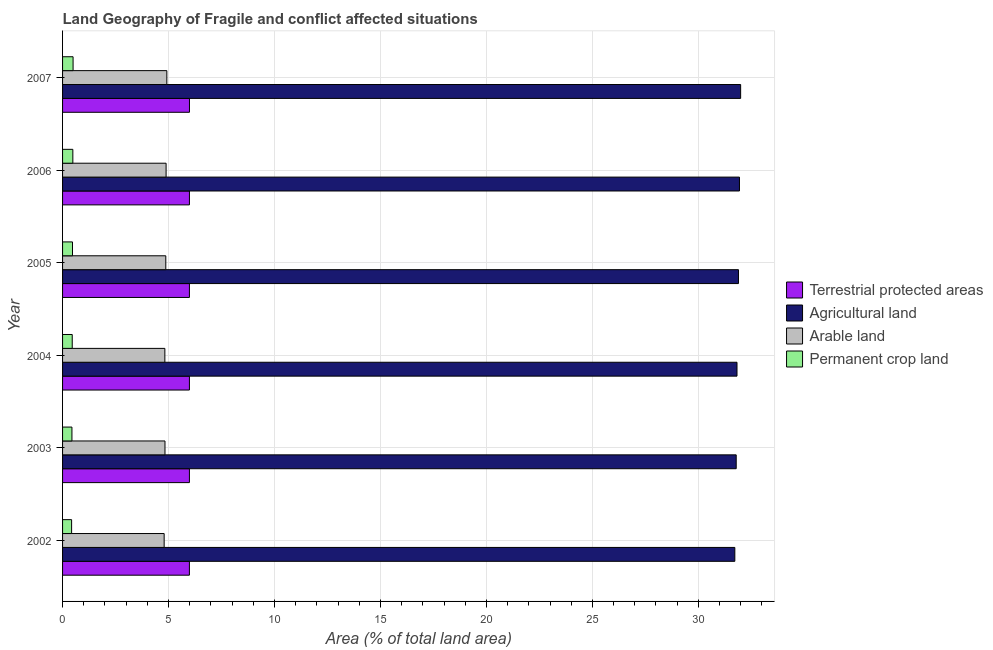How many different coloured bars are there?
Make the answer very short. 4. Are the number of bars per tick equal to the number of legend labels?
Make the answer very short. Yes. How many bars are there on the 5th tick from the top?
Ensure brevity in your answer.  4. How many bars are there on the 1st tick from the bottom?
Provide a short and direct response. 4. What is the label of the 2nd group of bars from the top?
Your answer should be compact. 2006. What is the percentage of land under terrestrial protection in 2002?
Give a very brief answer. 5.98. Across all years, what is the maximum percentage of area under arable land?
Your response must be concise. 4.92. Across all years, what is the minimum percentage of land under terrestrial protection?
Your response must be concise. 5.98. In which year was the percentage of land under terrestrial protection maximum?
Your answer should be very brief. 2007. In which year was the percentage of area under arable land minimum?
Your response must be concise. 2002. What is the total percentage of area under agricultural land in the graph?
Your answer should be compact. 191.16. What is the difference between the percentage of area under arable land in 2002 and that in 2005?
Provide a succinct answer. -0.08. What is the difference between the percentage of area under arable land in 2004 and the percentage of area under agricultural land in 2007?
Provide a succinct answer. -27.17. What is the average percentage of area under permanent crop land per year?
Your answer should be very brief. 0.46. In the year 2002, what is the difference between the percentage of land under terrestrial protection and percentage of area under agricultural land?
Your response must be concise. -25.74. In how many years, is the percentage of area under agricultural land greater than 26 %?
Offer a very short reply. 6. What is the ratio of the percentage of area under permanent crop land in 2005 to that in 2007?
Your answer should be very brief. 0.94. What is the difference between the highest and the second highest percentage of area under agricultural land?
Provide a succinct answer. 0.06. What is the difference between the highest and the lowest percentage of area under arable land?
Provide a short and direct response. 0.13. In how many years, is the percentage of area under permanent crop land greater than the average percentage of area under permanent crop land taken over all years?
Ensure brevity in your answer.  3. What does the 2nd bar from the top in 2007 represents?
Ensure brevity in your answer.  Arable land. What does the 1st bar from the bottom in 2003 represents?
Make the answer very short. Terrestrial protected areas. How many years are there in the graph?
Provide a succinct answer. 6. Where does the legend appear in the graph?
Provide a succinct answer. Center right. How many legend labels are there?
Offer a terse response. 4. What is the title of the graph?
Provide a succinct answer. Land Geography of Fragile and conflict affected situations. Does "Third 20% of population" appear as one of the legend labels in the graph?
Give a very brief answer. No. What is the label or title of the X-axis?
Ensure brevity in your answer.  Area (% of total land area). What is the Area (% of total land area) in Terrestrial protected areas in 2002?
Give a very brief answer. 5.98. What is the Area (% of total land area) in Agricultural land in 2002?
Your answer should be compact. 31.72. What is the Area (% of total land area) of Arable land in 2002?
Provide a succinct answer. 4.79. What is the Area (% of total land area) of Permanent crop land in 2002?
Your answer should be very brief. 0.43. What is the Area (% of total land area) in Terrestrial protected areas in 2003?
Give a very brief answer. 5.99. What is the Area (% of total land area) of Agricultural land in 2003?
Your answer should be compact. 31.79. What is the Area (% of total land area) in Arable land in 2003?
Offer a terse response. 4.83. What is the Area (% of total land area) of Permanent crop land in 2003?
Provide a succinct answer. 0.44. What is the Area (% of total land area) in Terrestrial protected areas in 2004?
Keep it short and to the point. 5.99. What is the Area (% of total land area) in Agricultural land in 2004?
Offer a terse response. 31.82. What is the Area (% of total land area) in Arable land in 2004?
Offer a terse response. 4.83. What is the Area (% of total land area) in Permanent crop land in 2004?
Your response must be concise. 0.46. What is the Area (% of total land area) of Terrestrial protected areas in 2005?
Provide a succinct answer. 5.99. What is the Area (% of total land area) of Agricultural land in 2005?
Offer a very short reply. 31.89. What is the Area (% of total land area) in Arable land in 2005?
Provide a short and direct response. 4.87. What is the Area (% of total land area) in Permanent crop land in 2005?
Your answer should be very brief. 0.47. What is the Area (% of total land area) of Terrestrial protected areas in 2006?
Keep it short and to the point. 5.99. What is the Area (% of total land area) in Agricultural land in 2006?
Your response must be concise. 31.94. What is the Area (% of total land area) in Arable land in 2006?
Offer a very short reply. 4.89. What is the Area (% of total land area) in Permanent crop land in 2006?
Make the answer very short. 0.48. What is the Area (% of total land area) in Terrestrial protected areas in 2007?
Your answer should be very brief. 5.99. What is the Area (% of total land area) of Agricultural land in 2007?
Ensure brevity in your answer.  32. What is the Area (% of total land area) of Arable land in 2007?
Give a very brief answer. 4.92. What is the Area (% of total land area) of Permanent crop land in 2007?
Provide a short and direct response. 0.5. Across all years, what is the maximum Area (% of total land area) in Terrestrial protected areas?
Ensure brevity in your answer.  5.99. Across all years, what is the maximum Area (% of total land area) in Agricultural land?
Your answer should be very brief. 32. Across all years, what is the maximum Area (% of total land area) in Arable land?
Offer a very short reply. 4.92. Across all years, what is the maximum Area (% of total land area) in Permanent crop land?
Ensure brevity in your answer.  0.5. Across all years, what is the minimum Area (% of total land area) in Terrestrial protected areas?
Offer a very short reply. 5.98. Across all years, what is the minimum Area (% of total land area) in Agricultural land?
Offer a very short reply. 31.72. Across all years, what is the minimum Area (% of total land area) in Arable land?
Your answer should be very brief. 4.79. Across all years, what is the minimum Area (% of total land area) in Permanent crop land?
Your answer should be very brief. 0.43. What is the total Area (% of total land area) of Terrestrial protected areas in the graph?
Make the answer very short. 35.92. What is the total Area (% of total land area) of Agricultural land in the graph?
Give a very brief answer. 191.16. What is the total Area (% of total land area) in Arable land in the graph?
Your answer should be very brief. 29.13. What is the total Area (% of total land area) in Permanent crop land in the graph?
Your response must be concise. 2.78. What is the difference between the Area (% of total land area) in Terrestrial protected areas in 2002 and that in 2003?
Offer a very short reply. -0. What is the difference between the Area (% of total land area) of Agricultural land in 2002 and that in 2003?
Your response must be concise. -0.07. What is the difference between the Area (% of total land area) of Arable land in 2002 and that in 2003?
Provide a short and direct response. -0.04. What is the difference between the Area (% of total land area) in Permanent crop land in 2002 and that in 2003?
Provide a succinct answer. -0.01. What is the difference between the Area (% of total land area) of Terrestrial protected areas in 2002 and that in 2004?
Ensure brevity in your answer.  -0. What is the difference between the Area (% of total land area) in Agricultural land in 2002 and that in 2004?
Your answer should be compact. -0.1. What is the difference between the Area (% of total land area) in Arable land in 2002 and that in 2004?
Provide a succinct answer. -0.03. What is the difference between the Area (% of total land area) in Permanent crop land in 2002 and that in 2004?
Provide a short and direct response. -0.03. What is the difference between the Area (% of total land area) in Terrestrial protected areas in 2002 and that in 2005?
Give a very brief answer. -0. What is the difference between the Area (% of total land area) of Agricultural land in 2002 and that in 2005?
Ensure brevity in your answer.  -0.17. What is the difference between the Area (% of total land area) in Arable land in 2002 and that in 2005?
Provide a short and direct response. -0.08. What is the difference between the Area (% of total land area) of Permanent crop land in 2002 and that in 2005?
Your answer should be very brief. -0.04. What is the difference between the Area (% of total land area) in Terrestrial protected areas in 2002 and that in 2006?
Make the answer very short. -0. What is the difference between the Area (% of total land area) of Agricultural land in 2002 and that in 2006?
Your answer should be very brief. -0.22. What is the difference between the Area (% of total land area) of Arable land in 2002 and that in 2006?
Offer a terse response. -0.09. What is the difference between the Area (% of total land area) of Permanent crop land in 2002 and that in 2006?
Your answer should be very brief. -0.06. What is the difference between the Area (% of total land area) in Terrestrial protected areas in 2002 and that in 2007?
Offer a very short reply. -0. What is the difference between the Area (% of total land area) of Agricultural land in 2002 and that in 2007?
Provide a short and direct response. -0.27. What is the difference between the Area (% of total land area) in Arable land in 2002 and that in 2007?
Give a very brief answer. -0.13. What is the difference between the Area (% of total land area) of Permanent crop land in 2002 and that in 2007?
Offer a very short reply. -0.07. What is the difference between the Area (% of total land area) in Terrestrial protected areas in 2003 and that in 2004?
Your answer should be compact. 0. What is the difference between the Area (% of total land area) of Agricultural land in 2003 and that in 2004?
Give a very brief answer. -0.04. What is the difference between the Area (% of total land area) of Arable land in 2003 and that in 2004?
Keep it short and to the point. 0.01. What is the difference between the Area (% of total land area) in Permanent crop land in 2003 and that in 2004?
Ensure brevity in your answer.  -0.01. What is the difference between the Area (% of total land area) of Agricultural land in 2003 and that in 2005?
Offer a terse response. -0.11. What is the difference between the Area (% of total land area) of Arable land in 2003 and that in 2005?
Your response must be concise. -0.04. What is the difference between the Area (% of total land area) of Permanent crop land in 2003 and that in 2005?
Your answer should be very brief. -0.03. What is the difference between the Area (% of total land area) of Terrestrial protected areas in 2003 and that in 2006?
Your response must be concise. -0. What is the difference between the Area (% of total land area) in Agricultural land in 2003 and that in 2006?
Make the answer very short. -0.15. What is the difference between the Area (% of total land area) of Arable land in 2003 and that in 2006?
Ensure brevity in your answer.  -0.05. What is the difference between the Area (% of total land area) of Permanent crop land in 2003 and that in 2006?
Your answer should be compact. -0.04. What is the difference between the Area (% of total land area) in Terrestrial protected areas in 2003 and that in 2007?
Make the answer very short. -0. What is the difference between the Area (% of total land area) of Agricultural land in 2003 and that in 2007?
Offer a terse response. -0.21. What is the difference between the Area (% of total land area) in Arable land in 2003 and that in 2007?
Offer a terse response. -0.09. What is the difference between the Area (% of total land area) in Permanent crop land in 2003 and that in 2007?
Ensure brevity in your answer.  -0.05. What is the difference between the Area (% of total land area) of Terrestrial protected areas in 2004 and that in 2005?
Keep it short and to the point. -0. What is the difference between the Area (% of total land area) of Agricultural land in 2004 and that in 2005?
Provide a succinct answer. -0.07. What is the difference between the Area (% of total land area) in Arable land in 2004 and that in 2005?
Make the answer very short. -0.04. What is the difference between the Area (% of total land area) in Permanent crop land in 2004 and that in 2005?
Ensure brevity in your answer.  -0.01. What is the difference between the Area (% of total land area) in Terrestrial protected areas in 2004 and that in 2006?
Your answer should be very brief. -0. What is the difference between the Area (% of total land area) in Agricultural land in 2004 and that in 2006?
Give a very brief answer. -0.12. What is the difference between the Area (% of total land area) in Arable land in 2004 and that in 2006?
Keep it short and to the point. -0.06. What is the difference between the Area (% of total land area) in Permanent crop land in 2004 and that in 2006?
Give a very brief answer. -0.03. What is the difference between the Area (% of total land area) of Terrestrial protected areas in 2004 and that in 2007?
Offer a terse response. -0. What is the difference between the Area (% of total land area) of Agricultural land in 2004 and that in 2007?
Offer a very short reply. -0.17. What is the difference between the Area (% of total land area) of Arable land in 2004 and that in 2007?
Provide a short and direct response. -0.09. What is the difference between the Area (% of total land area) in Permanent crop land in 2004 and that in 2007?
Keep it short and to the point. -0.04. What is the difference between the Area (% of total land area) of Terrestrial protected areas in 2005 and that in 2006?
Your answer should be very brief. -0. What is the difference between the Area (% of total land area) of Agricultural land in 2005 and that in 2006?
Ensure brevity in your answer.  -0.05. What is the difference between the Area (% of total land area) in Arable land in 2005 and that in 2006?
Your answer should be very brief. -0.01. What is the difference between the Area (% of total land area) in Permanent crop land in 2005 and that in 2006?
Offer a terse response. -0.02. What is the difference between the Area (% of total land area) of Terrestrial protected areas in 2005 and that in 2007?
Your answer should be compact. -0. What is the difference between the Area (% of total land area) of Agricultural land in 2005 and that in 2007?
Give a very brief answer. -0.1. What is the difference between the Area (% of total land area) of Arable land in 2005 and that in 2007?
Provide a succinct answer. -0.05. What is the difference between the Area (% of total land area) of Permanent crop land in 2005 and that in 2007?
Your response must be concise. -0.03. What is the difference between the Area (% of total land area) in Terrestrial protected areas in 2006 and that in 2007?
Your response must be concise. -0. What is the difference between the Area (% of total land area) of Agricultural land in 2006 and that in 2007?
Give a very brief answer. -0.05. What is the difference between the Area (% of total land area) in Arable land in 2006 and that in 2007?
Provide a short and direct response. -0.03. What is the difference between the Area (% of total land area) of Permanent crop land in 2006 and that in 2007?
Provide a short and direct response. -0.01. What is the difference between the Area (% of total land area) of Terrestrial protected areas in 2002 and the Area (% of total land area) of Agricultural land in 2003?
Make the answer very short. -25.8. What is the difference between the Area (% of total land area) in Terrestrial protected areas in 2002 and the Area (% of total land area) in Arable land in 2003?
Your answer should be compact. 1.15. What is the difference between the Area (% of total land area) in Terrestrial protected areas in 2002 and the Area (% of total land area) in Permanent crop land in 2003?
Your response must be concise. 5.54. What is the difference between the Area (% of total land area) in Agricultural land in 2002 and the Area (% of total land area) in Arable land in 2003?
Provide a succinct answer. 26.89. What is the difference between the Area (% of total land area) of Agricultural land in 2002 and the Area (% of total land area) of Permanent crop land in 2003?
Your answer should be very brief. 31.28. What is the difference between the Area (% of total land area) of Arable land in 2002 and the Area (% of total land area) of Permanent crop land in 2003?
Provide a succinct answer. 4.35. What is the difference between the Area (% of total land area) of Terrestrial protected areas in 2002 and the Area (% of total land area) of Agricultural land in 2004?
Provide a short and direct response. -25.84. What is the difference between the Area (% of total land area) of Terrestrial protected areas in 2002 and the Area (% of total land area) of Arable land in 2004?
Keep it short and to the point. 1.16. What is the difference between the Area (% of total land area) in Terrestrial protected areas in 2002 and the Area (% of total land area) in Permanent crop land in 2004?
Provide a succinct answer. 5.53. What is the difference between the Area (% of total land area) of Agricultural land in 2002 and the Area (% of total land area) of Arable land in 2004?
Ensure brevity in your answer.  26.89. What is the difference between the Area (% of total land area) of Agricultural land in 2002 and the Area (% of total land area) of Permanent crop land in 2004?
Your answer should be very brief. 31.27. What is the difference between the Area (% of total land area) in Arable land in 2002 and the Area (% of total land area) in Permanent crop land in 2004?
Ensure brevity in your answer.  4.34. What is the difference between the Area (% of total land area) of Terrestrial protected areas in 2002 and the Area (% of total land area) of Agricultural land in 2005?
Provide a short and direct response. -25.91. What is the difference between the Area (% of total land area) in Terrestrial protected areas in 2002 and the Area (% of total land area) in Arable land in 2005?
Make the answer very short. 1.11. What is the difference between the Area (% of total land area) of Terrestrial protected areas in 2002 and the Area (% of total land area) of Permanent crop land in 2005?
Your answer should be compact. 5.52. What is the difference between the Area (% of total land area) in Agricultural land in 2002 and the Area (% of total land area) in Arable land in 2005?
Your answer should be very brief. 26.85. What is the difference between the Area (% of total land area) in Agricultural land in 2002 and the Area (% of total land area) in Permanent crop land in 2005?
Ensure brevity in your answer.  31.25. What is the difference between the Area (% of total land area) in Arable land in 2002 and the Area (% of total land area) in Permanent crop land in 2005?
Give a very brief answer. 4.32. What is the difference between the Area (% of total land area) in Terrestrial protected areas in 2002 and the Area (% of total land area) in Agricultural land in 2006?
Offer a very short reply. -25.96. What is the difference between the Area (% of total land area) of Terrestrial protected areas in 2002 and the Area (% of total land area) of Arable land in 2006?
Ensure brevity in your answer.  1.1. What is the difference between the Area (% of total land area) in Terrestrial protected areas in 2002 and the Area (% of total land area) in Permanent crop land in 2006?
Provide a succinct answer. 5.5. What is the difference between the Area (% of total land area) in Agricultural land in 2002 and the Area (% of total land area) in Arable land in 2006?
Offer a very short reply. 26.84. What is the difference between the Area (% of total land area) of Agricultural land in 2002 and the Area (% of total land area) of Permanent crop land in 2006?
Your response must be concise. 31.24. What is the difference between the Area (% of total land area) of Arable land in 2002 and the Area (% of total land area) of Permanent crop land in 2006?
Provide a succinct answer. 4.31. What is the difference between the Area (% of total land area) of Terrestrial protected areas in 2002 and the Area (% of total land area) of Agricultural land in 2007?
Give a very brief answer. -26.01. What is the difference between the Area (% of total land area) in Terrestrial protected areas in 2002 and the Area (% of total land area) in Arable land in 2007?
Offer a terse response. 1.06. What is the difference between the Area (% of total land area) in Terrestrial protected areas in 2002 and the Area (% of total land area) in Permanent crop land in 2007?
Your answer should be compact. 5.49. What is the difference between the Area (% of total land area) in Agricultural land in 2002 and the Area (% of total land area) in Arable land in 2007?
Provide a succinct answer. 26.8. What is the difference between the Area (% of total land area) in Agricultural land in 2002 and the Area (% of total land area) in Permanent crop land in 2007?
Ensure brevity in your answer.  31.23. What is the difference between the Area (% of total land area) in Arable land in 2002 and the Area (% of total land area) in Permanent crop land in 2007?
Your response must be concise. 4.3. What is the difference between the Area (% of total land area) of Terrestrial protected areas in 2003 and the Area (% of total land area) of Agricultural land in 2004?
Provide a succinct answer. -25.84. What is the difference between the Area (% of total land area) in Terrestrial protected areas in 2003 and the Area (% of total land area) in Arable land in 2004?
Offer a very short reply. 1.16. What is the difference between the Area (% of total land area) of Terrestrial protected areas in 2003 and the Area (% of total land area) of Permanent crop land in 2004?
Offer a terse response. 5.53. What is the difference between the Area (% of total land area) in Agricultural land in 2003 and the Area (% of total land area) in Arable land in 2004?
Provide a short and direct response. 26.96. What is the difference between the Area (% of total land area) in Agricultural land in 2003 and the Area (% of total land area) in Permanent crop land in 2004?
Provide a short and direct response. 31.33. What is the difference between the Area (% of total land area) in Arable land in 2003 and the Area (% of total land area) in Permanent crop land in 2004?
Provide a succinct answer. 4.38. What is the difference between the Area (% of total land area) of Terrestrial protected areas in 2003 and the Area (% of total land area) of Agricultural land in 2005?
Ensure brevity in your answer.  -25.91. What is the difference between the Area (% of total land area) in Terrestrial protected areas in 2003 and the Area (% of total land area) in Arable land in 2005?
Your answer should be compact. 1.12. What is the difference between the Area (% of total land area) of Terrestrial protected areas in 2003 and the Area (% of total land area) of Permanent crop land in 2005?
Your response must be concise. 5.52. What is the difference between the Area (% of total land area) in Agricultural land in 2003 and the Area (% of total land area) in Arable land in 2005?
Keep it short and to the point. 26.92. What is the difference between the Area (% of total land area) of Agricultural land in 2003 and the Area (% of total land area) of Permanent crop land in 2005?
Offer a terse response. 31.32. What is the difference between the Area (% of total land area) of Arable land in 2003 and the Area (% of total land area) of Permanent crop land in 2005?
Your answer should be very brief. 4.36. What is the difference between the Area (% of total land area) in Terrestrial protected areas in 2003 and the Area (% of total land area) in Agricultural land in 2006?
Offer a very short reply. -25.95. What is the difference between the Area (% of total land area) of Terrestrial protected areas in 2003 and the Area (% of total land area) of Arable land in 2006?
Offer a terse response. 1.1. What is the difference between the Area (% of total land area) in Terrestrial protected areas in 2003 and the Area (% of total land area) in Permanent crop land in 2006?
Provide a succinct answer. 5.5. What is the difference between the Area (% of total land area) of Agricultural land in 2003 and the Area (% of total land area) of Arable land in 2006?
Provide a short and direct response. 26.9. What is the difference between the Area (% of total land area) in Agricultural land in 2003 and the Area (% of total land area) in Permanent crop land in 2006?
Your answer should be compact. 31.3. What is the difference between the Area (% of total land area) of Arable land in 2003 and the Area (% of total land area) of Permanent crop land in 2006?
Provide a succinct answer. 4.35. What is the difference between the Area (% of total land area) of Terrestrial protected areas in 2003 and the Area (% of total land area) of Agricultural land in 2007?
Offer a very short reply. -26.01. What is the difference between the Area (% of total land area) of Terrestrial protected areas in 2003 and the Area (% of total land area) of Arable land in 2007?
Ensure brevity in your answer.  1.07. What is the difference between the Area (% of total land area) of Terrestrial protected areas in 2003 and the Area (% of total land area) of Permanent crop land in 2007?
Keep it short and to the point. 5.49. What is the difference between the Area (% of total land area) of Agricultural land in 2003 and the Area (% of total land area) of Arable land in 2007?
Offer a very short reply. 26.87. What is the difference between the Area (% of total land area) of Agricultural land in 2003 and the Area (% of total land area) of Permanent crop land in 2007?
Provide a succinct answer. 31.29. What is the difference between the Area (% of total land area) in Arable land in 2003 and the Area (% of total land area) in Permanent crop land in 2007?
Your answer should be very brief. 4.34. What is the difference between the Area (% of total land area) of Terrestrial protected areas in 2004 and the Area (% of total land area) of Agricultural land in 2005?
Your answer should be very brief. -25.91. What is the difference between the Area (% of total land area) in Terrestrial protected areas in 2004 and the Area (% of total land area) in Arable land in 2005?
Your answer should be compact. 1.12. What is the difference between the Area (% of total land area) of Terrestrial protected areas in 2004 and the Area (% of total land area) of Permanent crop land in 2005?
Your response must be concise. 5.52. What is the difference between the Area (% of total land area) of Agricultural land in 2004 and the Area (% of total land area) of Arable land in 2005?
Offer a terse response. 26.95. What is the difference between the Area (% of total land area) of Agricultural land in 2004 and the Area (% of total land area) of Permanent crop land in 2005?
Your answer should be compact. 31.36. What is the difference between the Area (% of total land area) in Arable land in 2004 and the Area (% of total land area) in Permanent crop land in 2005?
Your answer should be very brief. 4.36. What is the difference between the Area (% of total land area) of Terrestrial protected areas in 2004 and the Area (% of total land area) of Agricultural land in 2006?
Your response must be concise. -25.95. What is the difference between the Area (% of total land area) of Terrestrial protected areas in 2004 and the Area (% of total land area) of Arable land in 2006?
Make the answer very short. 1.1. What is the difference between the Area (% of total land area) of Terrestrial protected areas in 2004 and the Area (% of total land area) of Permanent crop land in 2006?
Provide a succinct answer. 5.5. What is the difference between the Area (% of total land area) in Agricultural land in 2004 and the Area (% of total land area) in Arable land in 2006?
Ensure brevity in your answer.  26.94. What is the difference between the Area (% of total land area) in Agricultural land in 2004 and the Area (% of total land area) in Permanent crop land in 2006?
Make the answer very short. 31.34. What is the difference between the Area (% of total land area) of Arable land in 2004 and the Area (% of total land area) of Permanent crop land in 2006?
Provide a succinct answer. 4.34. What is the difference between the Area (% of total land area) of Terrestrial protected areas in 2004 and the Area (% of total land area) of Agricultural land in 2007?
Give a very brief answer. -26.01. What is the difference between the Area (% of total land area) in Terrestrial protected areas in 2004 and the Area (% of total land area) in Arable land in 2007?
Your response must be concise. 1.07. What is the difference between the Area (% of total land area) of Terrestrial protected areas in 2004 and the Area (% of total land area) of Permanent crop land in 2007?
Your answer should be compact. 5.49. What is the difference between the Area (% of total land area) of Agricultural land in 2004 and the Area (% of total land area) of Arable land in 2007?
Give a very brief answer. 26.9. What is the difference between the Area (% of total land area) of Agricultural land in 2004 and the Area (% of total land area) of Permanent crop land in 2007?
Keep it short and to the point. 31.33. What is the difference between the Area (% of total land area) of Arable land in 2004 and the Area (% of total land area) of Permanent crop land in 2007?
Offer a very short reply. 4.33. What is the difference between the Area (% of total land area) of Terrestrial protected areas in 2005 and the Area (% of total land area) of Agricultural land in 2006?
Your response must be concise. -25.95. What is the difference between the Area (% of total land area) of Terrestrial protected areas in 2005 and the Area (% of total land area) of Arable land in 2006?
Offer a terse response. 1.1. What is the difference between the Area (% of total land area) in Terrestrial protected areas in 2005 and the Area (% of total land area) in Permanent crop land in 2006?
Make the answer very short. 5.5. What is the difference between the Area (% of total land area) of Agricultural land in 2005 and the Area (% of total land area) of Arable land in 2006?
Your answer should be compact. 27.01. What is the difference between the Area (% of total land area) of Agricultural land in 2005 and the Area (% of total land area) of Permanent crop land in 2006?
Offer a terse response. 31.41. What is the difference between the Area (% of total land area) of Arable land in 2005 and the Area (% of total land area) of Permanent crop land in 2006?
Provide a succinct answer. 4.39. What is the difference between the Area (% of total land area) of Terrestrial protected areas in 2005 and the Area (% of total land area) of Agricultural land in 2007?
Give a very brief answer. -26.01. What is the difference between the Area (% of total land area) in Terrestrial protected areas in 2005 and the Area (% of total land area) in Arable land in 2007?
Give a very brief answer. 1.07. What is the difference between the Area (% of total land area) of Terrestrial protected areas in 2005 and the Area (% of total land area) of Permanent crop land in 2007?
Give a very brief answer. 5.49. What is the difference between the Area (% of total land area) in Agricultural land in 2005 and the Area (% of total land area) in Arable land in 2007?
Ensure brevity in your answer.  26.97. What is the difference between the Area (% of total land area) in Agricultural land in 2005 and the Area (% of total land area) in Permanent crop land in 2007?
Offer a very short reply. 31.4. What is the difference between the Area (% of total land area) in Arable land in 2005 and the Area (% of total land area) in Permanent crop land in 2007?
Your answer should be compact. 4.37. What is the difference between the Area (% of total land area) of Terrestrial protected areas in 2006 and the Area (% of total land area) of Agricultural land in 2007?
Provide a short and direct response. -26.01. What is the difference between the Area (% of total land area) of Terrestrial protected areas in 2006 and the Area (% of total land area) of Arable land in 2007?
Offer a very short reply. 1.07. What is the difference between the Area (% of total land area) of Terrestrial protected areas in 2006 and the Area (% of total land area) of Permanent crop land in 2007?
Make the answer very short. 5.49. What is the difference between the Area (% of total land area) in Agricultural land in 2006 and the Area (% of total land area) in Arable land in 2007?
Keep it short and to the point. 27.02. What is the difference between the Area (% of total land area) of Agricultural land in 2006 and the Area (% of total land area) of Permanent crop land in 2007?
Make the answer very short. 31.44. What is the difference between the Area (% of total land area) in Arable land in 2006 and the Area (% of total land area) in Permanent crop land in 2007?
Your answer should be compact. 4.39. What is the average Area (% of total land area) of Terrestrial protected areas per year?
Offer a very short reply. 5.99. What is the average Area (% of total land area) in Agricultural land per year?
Make the answer very short. 31.86. What is the average Area (% of total land area) in Arable land per year?
Offer a terse response. 4.85. What is the average Area (% of total land area) in Permanent crop land per year?
Your answer should be compact. 0.46. In the year 2002, what is the difference between the Area (% of total land area) in Terrestrial protected areas and Area (% of total land area) in Agricultural land?
Keep it short and to the point. -25.74. In the year 2002, what is the difference between the Area (% of total land area) of Terrestrial protected areas and Area (% of total land area) of Arable land?
Provide a short and direct response. 1.19. In the year 2002, what is the difference between the Area (% of total land area) in Terrestrial protected areas and Area (% of total land area) in Permanent crop land?
Keep it short and to the point. 5.56. In the year 2002, what is the difference between the Area (% of total land area) of Agricultural land and Area (% of total land area) of Arable land?
Your response must be concise. 26.93. In the year 2002, what is the difference between the Area (% of total land area) of Agricultural land and Area (% of total land area) of Permanent crop land?
Your answer should be compact. 31.29. In the year 2002, what is the difference between the Area (% of total land area) in Arable land and Area (% of total land area) in Permanent crop land?
Keep it short and to the point. 4.37. In the year 2003, what is the difference between the Area (% of total land area) of Terrestrial protected areas and Area (% of total land area) of Agricultural land?
Your answer should be compact. -25.8. In the year 2003, what is the difference between the Area (% of total land area) in Terrestrial protected areas and Area (% of total land area) in Arable land?
Give a very brief answer. 1.15. In the year 2003, what is the difference between the Area (% of total land area) of Terrestrial protected areas and Area (% of total land area) of Permanent crop land?
Ensure brevity in your answer.  5.54. In the year 2003, what is the difference between the Area (% of total land area) in Agricultural land and Area (% of total land area) in Arable land?
Make the answer very short. 26.95. In the year 2003, what is the difference between the Area (% of total land area) in Agricultural land and Area (% of total land area) in Permanent crop land?
Your answer should be very brief. 31.34. In the year 2003, what is the difference between the Area (% of total land area) of Arable land and Area (% of total land area) of Permanent crop land?
Keep it short and to the point. 4.39. In the year 2004, what is the difference between the Area (% of total land area) in Terrestrial protected areas and Area (% of total land area) in Agricultural land?
Make the answer very short. -25.84. In the year 2004, what is the difference between the Area (% of total land area) of Terrestrial protected areas and Area (% of total land area) of Arable land?
Your response must be concise. 1.16. In the year 2004, what is the difference between the Area (% of total land area) of Terrestrial protected areas and Area (% of total land area) of Permanent crop land?
Give a very brief answer. 5.53. In the year 2004, what is the difference between the Area (% of total land area) in Agricultural land and Area (% of total land area) in Arable land?
Provide a short and direct response. 27. In the year 2004, what is the difference between the Area (% of total land area) in Agricultural land and Area (% of total land area) in Permanent crop land?
Ensure brevity in your answer.  31.37. In the year 2004, what is the difference between the Area (% of total land area) of Arable land and Area (% of total land area) of Permanent crop land?
Keep it short and to the point. 4.37. In the year 2005, what is the difference between the Area (% of total land area) in Terrestrial protected areas and Area (% of total land area) in Agricultural land?
Ensure brevity in your answer.  -25.91. In the year 2005, what is the difference between the Area (% of total land area) of Terrestrial protected areas and Area (% of total land area) of Arable land?
Provide a succinct answer. 1.12. In the year 2005, what is the difference between the Area (% of total land area) of Terrestrial protected areas and Area (% of total land area) of Permanent crop land?
Make the answer very short. 5.52. In the year 2005, what is the difference between the Area (% of total land area) of Agricultural land and Area (% of total land area) of Arable land?
Offer a very short reply. 27.02. In the year 2005, what is the difference between the Area (% of total land area) of Agricultural land and Area (% of total land area) of Permanent crop land?
Your answer should be very brief. 31.42. In the year 2005, what is the difference between the Area (% of total land area) of Arable land and Area (% of total land area) of Permanent crop land?
Your response must be concise. 4.4. In the year 2006, what is the difference between the Area (% of total land area) of Terrestrial protected areas and Area (% of total land area) of Agricultural land?
Provide a short and direct response. -25.95. In the year 2006, what is the difference between the Area (% of total land area) in Terrestrial protected areas and Area (% of total land area) in Arable land?
Give a very brief answer. 1.1. In the year 2006, what is the difference between the Area (% of total land area) of Terrestrial protected areas and Area (% of total land area) of Permanent crop land?
Give a very brief answer. 5.5. In the year 2006, what is the difference between the Area (% of total land area) of Agricultural land and Area (% of total land area) of Arable land?
Your response must be concise. 27.06. In the year 2006, what is the difference between the Area (% of total land area) in Agricultural land and Area (% of total land area) in Permanent crop land?
Give a very brief answer. 31.46. In the year 2006, what is the difference between the Area (% of total land area) in Arable land and Area (% of total land area) in Permanent crop land?
Offer a very short reply. 4.4. In the year 2007, what is the difference between the Area (% of total land area) in Terrestrial protected areas and Area (% of total land area) in Agricultural land?
Ensure brevity in your answer.  -26.01. In the year 2007, what is the difference between the Area (% of total land area) of Terrestrial protected areas and Area (% of total land area) of Arable land?
Offer a terse response. 1.07. In the year 2007, what is the difference between the Area (% of total land area) in Terrestrial protected areas and Area (% of total land area) in Permanent crop land?
Give a very brief answer. 5.49. In the year 2007, what is the difference between the Area (% of total land area) of Agricultural land and Area (% of total land area) of Arable land?
Make the answer very short. 27.08. In the year 2007, what is the difference between the Area (% of total land area) of Agricultural land and Area (% of total land area) of Permanent crop land?
Keep it short and to the point. 31.5. In the year 2007, what is the difference between the Area (% of total land area) of Arable land and Area (% of total land area) of Permanent crop land?
Ensure brevity in your answer.  4.42. What is the ratio of the Area (% of total land area) of Agricultural land in 2002 to that in 2003?
Your answer should be very brief. 1. What is the ratio of the Area (% of total land area) in Permanent crop land in 2002 to that in 2003?
Give a very brief answer. 0.97. What is the ratio of the Area (% of total land area) in Terrestrial protected areas in 2002 to that in 2004?
Provide a short and direct response. 1. What is the ratio of the Area (% of total land area) of Arable land in 2002 to that in 2004?
Ensure brevity in your answer.  0.99. What is the ratio of the Area (% of total land area) in Permanent crop land in 2002 to that in 2004?
Provide a short and direct response. 0.94. What is the ratio of the Area (% of total land area) of Terrestrial protected areas in 2002 to that in 2005?
Your answer should be very brief. 1. What is the ratio of the Area (% of total land area) in Arable land in 2002 to that in 2005?
Your answer should be very brief. 0.98. What is the ratio of the Area (% of total land area) in Permanent crop land in 2002 to that in 2005?
Provide a succinct answer. 0.91. What is the ratio of the Area (% of total land area) of Terrestrial protected areas in 2002 to that in 2006?
Your response must be concise. 1. What is the ratio of the Area (% of total land area) in Arable land in 2002 to that in 2006?
Your response must be concise. 0.98. What is the ratio of the Area (% of total land area) of Permanent crop land in 2002 to that in 2006?
Your answer should be very brief. 0.88. What is the ratio of the Area (% of total land area) in Terrestrial protected areas in 2002 to that in 2007?
Offer a terse response. 1. What is the ratio of the Area (% of total land area) of Agricultural land in 2002 to that in 2007?
Offer a terse response. 0.99. What is the ratio of the Area (% of total land area) of Arable land in 2002 to that in 2007?
Your response must be concise. 0.97. What is the ratio of the Area (% of total land area) in Permanent crop land in 2002 to that in 2007?
Offer a terse response. 0.86. What is the ratio of the Area (% of total land area) in Agricultural land in 2003 to that in 2004?
Provide a succinct answer. 1. What is the ratio of the Area (% of total land area) in Arable land in 2003 to that in 2004?
Provide a short and direct response. 1. What is the ratio of the Area (% of total land area) of Permanent crop land in 2003 to that in 2004?
Give a very brief answer. 0.97. What is the ratio of the Area (% of total land area) in Permanent crop land in 2003 to that in 2005?
Your response must be concise. 0.94. What is the ratio of the Area (% of total land area) of Terrestrial protected areas in 2003 to that in 2006?
Make the answer very short. 1. What is the ratio of the Area (% of total land area) in Arable land in 2003 to that in 2006?
Provide a short and direct response. 0.99. What is the ratio of the Area (% of total land area) in Permanent crop land in 2003 to that in 2006?
Ensure brevity in your answer.  0.91. What is the ratio of the Area (% of total land area) in Terrestrial protected areas in 2003 to that in 2007?
Provide a short and direct response. 1. What is the ratio of the Area (% of total land area) of Arable land in 2003 to that in 2007?
Make the answer very short. 0.98. What is the ratio of the Area (% of total land area) of Permanent crop land in 2003 to that in 2007?
Your answer should be very brief. 0.89. What is the ratio of the Area (% of total land area) in Arable land in 2004 to that in 2005?
Your answer should be very brief. 0.99. What is the ratio of the Area (% of total land area) in Permanent crop land in 2004 to that in 2005?
Provide a succinct answer. 0.97. What is the ratio of the Area (% of total land area) of Terrestrial protected areas in 2004 to that in 2006?
Your answer should be compact. 1. What is the ratio of the Area (% of total land area) of Agricultural land in 2004 to that in 2006?
Give a very brief answer. 1. What is the ratio of the Area (% of total land area) in Arable land in 2004 to that in 2006?
Provide a succinct answer. 0.99. What is the ratio of the Area (% of total land area) of Permanent crop land in 2004 to that in 2006?
Ensure brevity in your answer.  0.94. What is the ratio of the Area (% of total land area) of Terrestrial protected areas in 2004 to that in 2007?
Your answer should be very brief. 1. What is the ratio of the Area (% of total land area) of Agricultural land in 2004 to that in 2007?
Ensure brevity in your answer.  0.99. What is the ratio of the Area (% of total land area) in Permanent crop land in 2004 to that in 2007?
Your response must be concise. 0.92. What is the ratio of the Area (% of total land area) in Terrestrial protected areas in 2005 to that in 2006?
Your answer should be very brief. 1. What is the ratio of the Area (% of total land area) in Agricultural land in 2005 to that in 2006?
Provide a short and direct response. 1. What is the ratio of the Area (% of total land area) of Arable land in 2005 to that in 2006?
Your response must be concise. 1. What is the ratio of the Area (% of total land area) in Permanent crop land in 2005 to that in 2006?
Offer a very short reply. 0.97. What is the ratio of the Area (% of total land area) in Terrestrial protected areas in 2005 to that in 2007?
Make the answer very short. 1. What is the ratio of the Area (% of total land area) in Agricultural land in 2005 to that in 2007?
Keep it short and to the point. 1. What is the ratio of the Area (% of total land area) of Arable land in 2005 to that in 2007?
Your answer should be compact. 0.99. What is the ratio of the Area (% of total land area) of Permanent crop land in 2005 to that in 2007?
Your response must be concise. 0.95. What is the ratio of the Area (% of total land area) of Terrestrial protected areas in 2006 to that in 2007?
Your answer should be very brief. 1. What is the ratio of the Area (% of total land area) of Agricultural land in 2006 to that in 2007?
Provide a succinct answer. 1. What is the ratio of the Area (% of total land area) of Permanent crop land in 2006 to that in 2007?
Offer a very short reply. 0.98. What is the difference between the highest and the second highest Area (% of total land area) of Terrestrial protected areas?
Your answer should be very brief. 0. What is the difference between the highest and the second highest Area (% of total land area) in Agricultural land?
Offer a terse response. 0.05. What is the difference between the highest and the second highest Area (% of total land area) in Arable land?
Your answer should be very brief. 0.03. What is the difference between the highest and the second highest Area (% of total land area) of Permanent crop land?
Provide a succinct answer. 0.01. What is the difference between the highest and the lowest Area (% of total land area) of Terrestrial protected areas?
Provide a succinct answer. 0. What is the difference between the highest and the lowest Area (% of total land area) in Agricultural land?
Your answer should be compact. 0.27. What is the difference between the highest and the lowest Area (% of total land area) in Arable land?
Offer a very short reply. 0.13. What is the difference between the highest and the lowest Area (% of total land area) in Permanent crop land?
Provide a succinct answer. 0.07. 